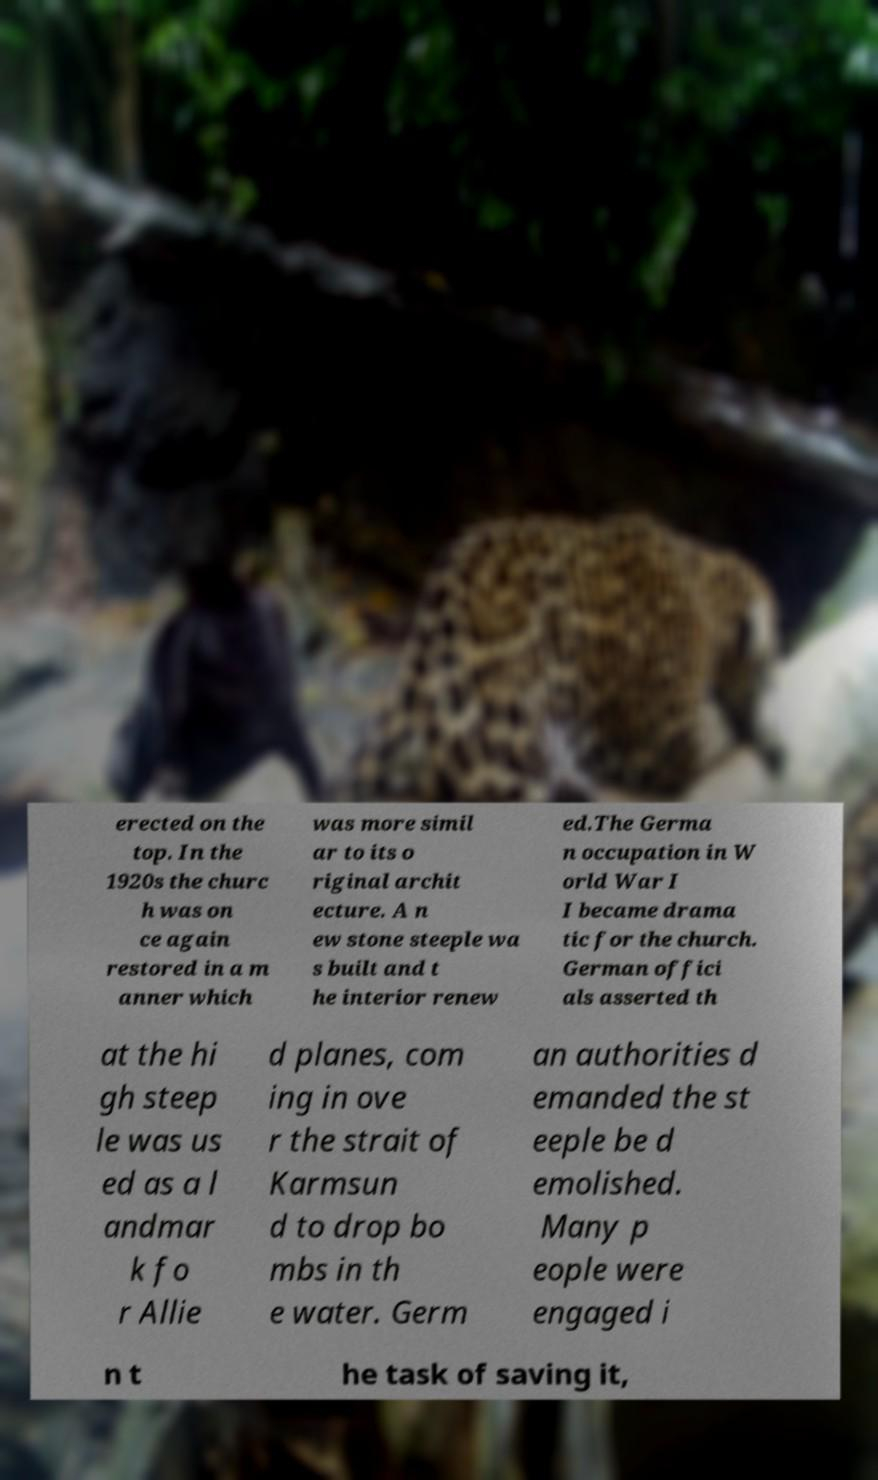I need the written content from this picture converted into text. Can you do that? erected on the top. In the 1920s the churc h was on ce again restored in a m anner which was more simil ar to its o riginal archit ecture. A n ew stone steeple wa s built and t he interior renew ed.The Germa n occupation in W orld War I I became drama tic for the church. German offici als asserted th at the hi gh steep le was us ed as a l andmar k fo r Allie d planes, com ing in ove r the strait of Karmsun d to drop bo mbs in th e water. Germ an authorities d emanded the st eeple be d emolished. Many p eople were engaged i n t he task of saving it, 